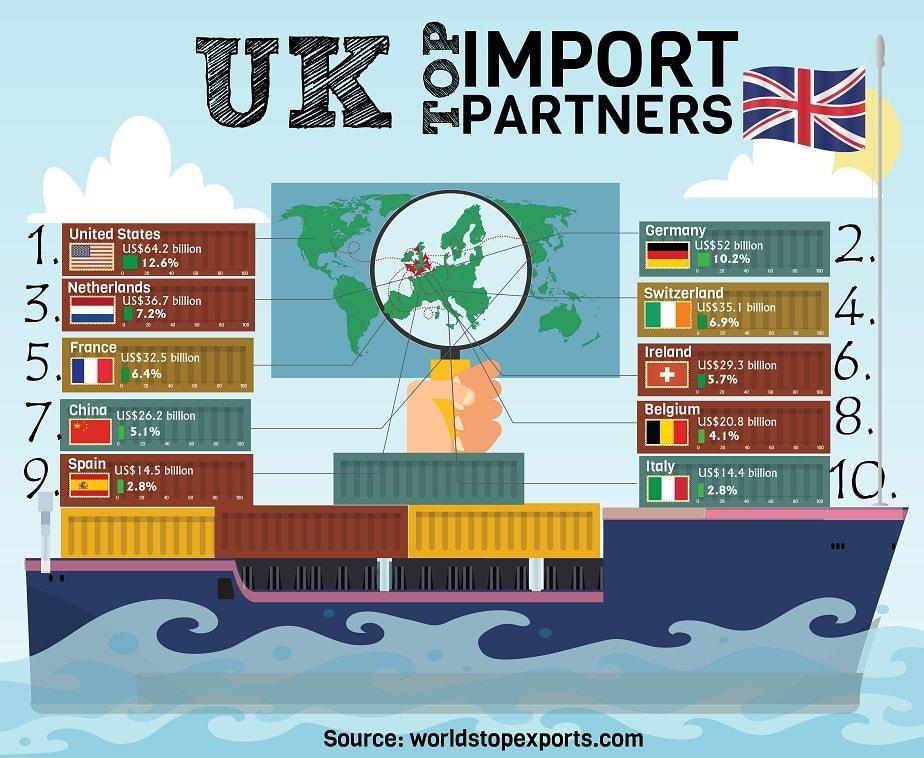Highlight a few significant elements in this photo. The United Kingdom's imports to Germany accounted for 10.2% of its total imports. According to data, the Netherlands imported 7.2% of its goods from the United Kingdom in 2021. The United States is the top import partner of the United Kingdom. 